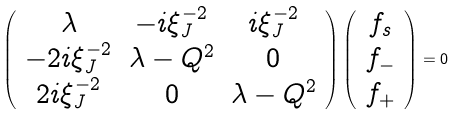<formula> <loc_0><loc_0><loc_500><loc_500>\left ( \begin{array} { c c c } \lambda & - i \xi _ { J } ^ { - 2 } & i \xi _ { J } ^ { - 2 } \\ - 2 i \xi _ { J } ^ { - 2 } & \lambda - Q ^ { 2 } & 0 \\ 2 i \xi _ { J } ^ { - 2 } & 0 & \lambda - Q ^ { 2 } \end{array} \right ) \left ( \begin{array} { c } f _ { s } \\ f _ { - } \\ f _ { + } \end{array} \right ) = 0</formula> 